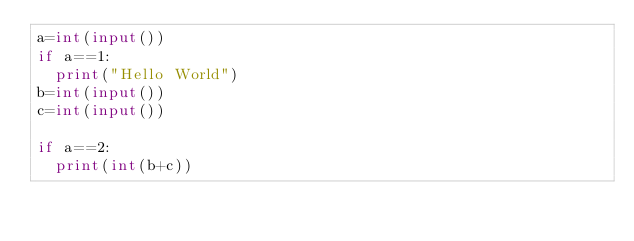<code> <loc_0><loc_0><loc_500><loc_500><_Python_>a=int(input())
if a==1:
  print("Hello World")
b=int(input())
c=int(input())

if a==2:
  print(int(b+c))</code> 